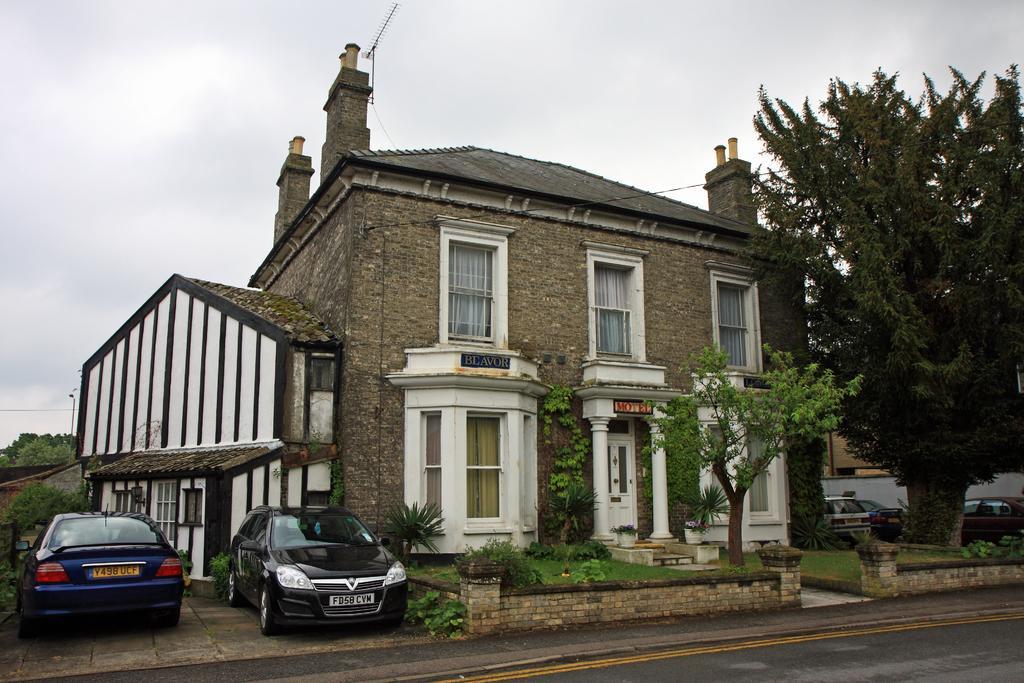Could you give a brief overview of what you see in this image? In this image, we can see the house, walls, windows, doors, pillars, curtains and stairs. Here we can see few plants, walkway. At the bottom, there is a road. Here we can see few vehicles and trees. Background there is a sky. 